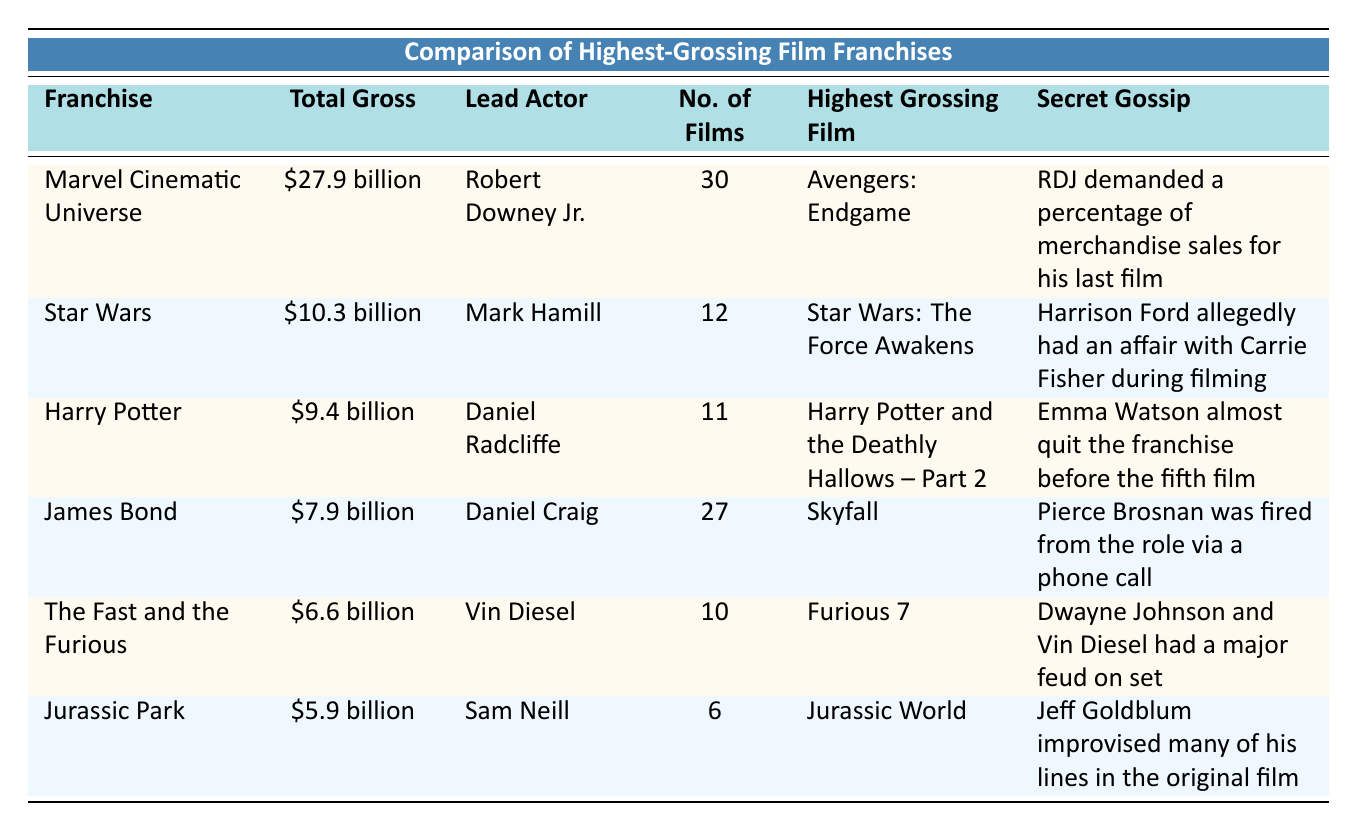What is the total gross of the Marvel Cinematic Universe? The table lists the total gross of the Marvel Cinematic Universe as $27.9 billion.
Answer: $27.9 billion Which lead actor is associated with the Harry Potter franchise? The table specifies that the lead actor for the Harry Potter franchise is Daniel Radcliffe.
Answer: Daniel Radcliffe How many films are there in the Star Wars franchise? According to the table, the number of films in the Star Wars franchise is 12.
Answer: 12 What is the highest-grossing film of the James Bond franchise? The table indicates that the highest-grossing film for the James Bond franchise is Skyfall.
Answer: Skyfall Is the total gross of the Jurassic Park franchise higher than that of the Fast and the Furious franchise? The total gross for Jurassic Park is $5.9 billion, and for Fast and the Furious, it's $6.6 billion. Since $5.9 billion is less than $6.6 billion, the statement is false.
Answer: No What is the combined total gross of the top two franchises listed? The total gross of the Marvel Cinematic Universe is $27.9 billion and the Star Wars franchise is $10.3 billion. Adding these gives $27.9 billion + $10.3 billion = $38.2 billion.
Answer: $38.2 billion Does Daniel Craig star in more films than Sam Neill? The table shows that Daniel Craig is in 27 films while Sam Neill is in 6 films. Since 27 is greater than 6, the statement is true.
Answer: Yes Which franchise has the lowest total gross, and what is it? The franchise with the lowest total gross is Jurassic Park at $5.9 billion, as listed in the table.
Answer: Jurassic Park, $5.9 billion If we compare the number of films, which franchise has more films: Harry Potter or The Fast and the Furious? Harry Potter has 11 films, and The Fast and the Furious has 10 films as per the table. Since 11 is greater than 10, Harry Potter has more films.
Answer: Harry Potter What secret gossip is associated with the lead actor of the Marvel Cinematic Universe? The table mentions that Robert Downey Jr. demanded a percentage of merchandise sales for his last film.
Answer: RDJ demanded a percentage of merchandise sales for his last film 